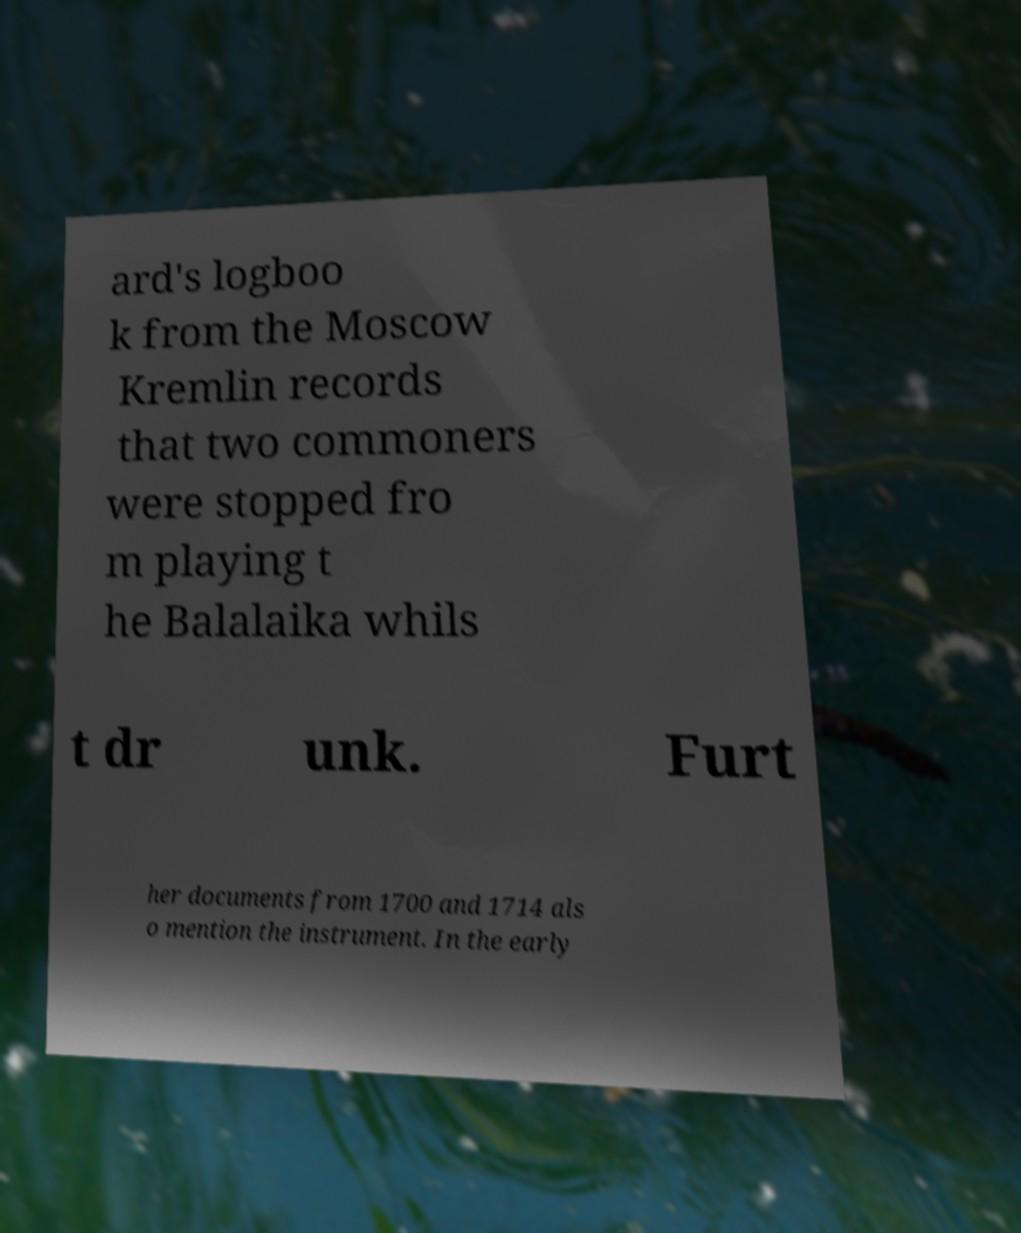Please read and relay the text visible in this image. What does it say? ard's logboo k from the Moscow Kremlin records that two commoners were stopped fro m playing t he Balalaika whils t dr unk. Furt her documents from 1700 and 1714 als o mention the instrument. In the early 